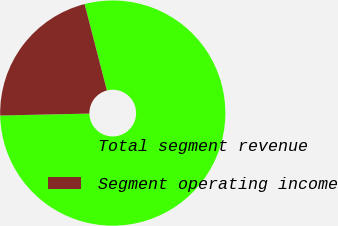Convert chart to OTSL. <chart><loc_0><loc_0><loc_500><loc_500><pie_chart><fcel>Total segment revenue<fcel>Segment operating income<nl><fcel>78.68%<fcel>21.32%<nl></chart> 